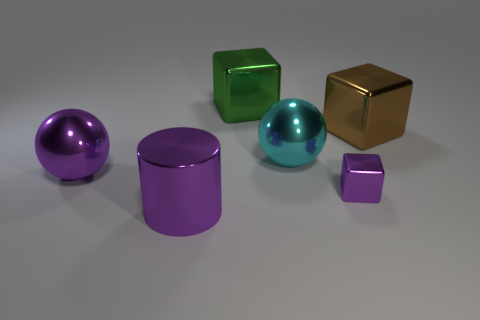Add 3 big green metal cubes. How many objects exist? 9 Subtract all large green cubes. How many cubes are left? 2 Subtract all purple blocks. How many blocks are left? 2 Subtract all green cylinders. How many purple spheres are left? 1 Subtract 1 cubes. How many cubes are left? 2 Subtract all green cylinders. Subtract all small objects. How many objects are left? 5 Add 4 metallic cylinders. How many metallic cylinders are left? 5 Add 6 blocks. How many blocks exist? 9 Subtract 0 brown spheres. How many objects are left? 6 Subtract all cylinders. How many objects are left? 5 